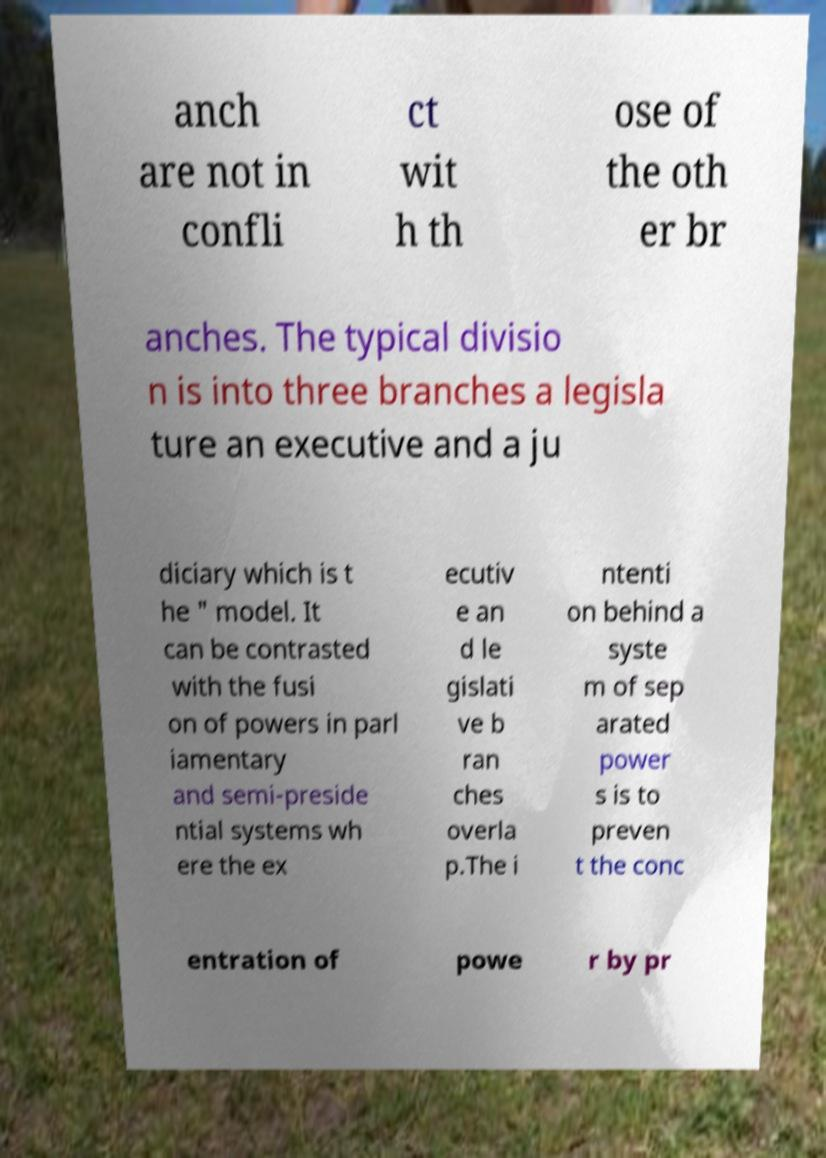Can you accurately transcribe the text from the provided image for me? anch are not in confli ct wit h th ose of the oth er br anches. The typical divisio n is into three branches a legisla ture an executive and a ju diciary which is t he " model. It can be contrasted with the fusi on of powers in parl iamentary and semi-preside ntial systems wh ere the ex ecutiv e an d le gislati ve b ran ches overla p.The i ntenti on behind a syste m of sep arated power s is to preven t the conc entration of powe r by pr 